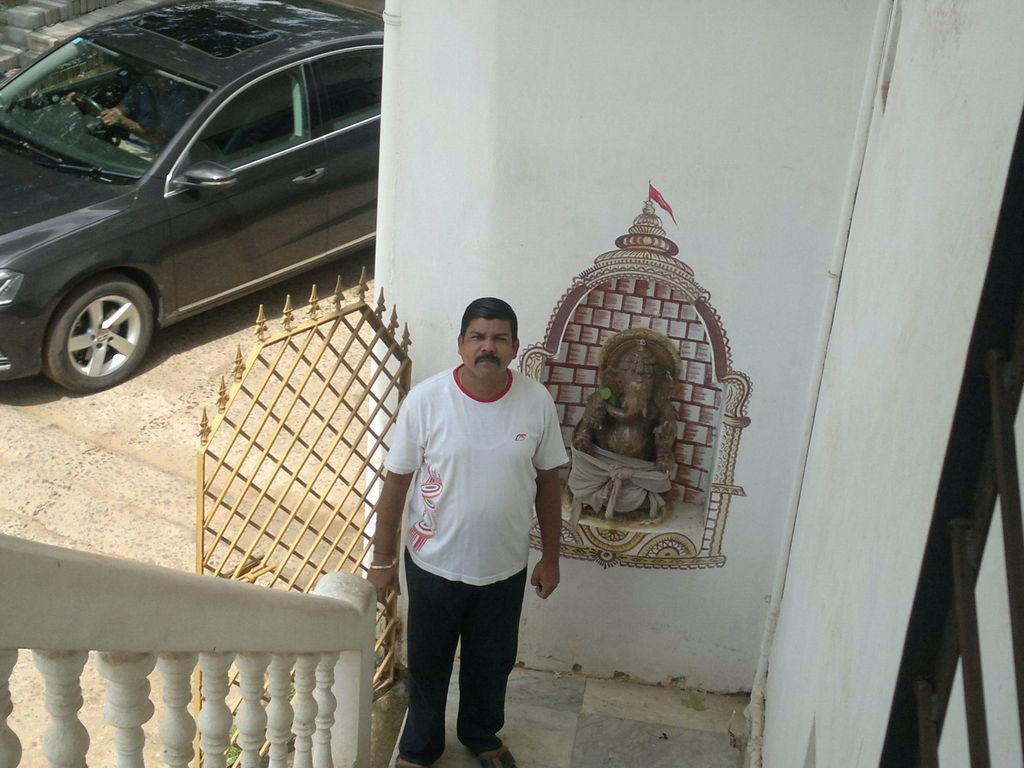What is the main subject in the image? There is a person standing in the image. What can be seen behind the person? There is a wall in the image. What is located near the wall? There is a car in the image. What type of surface is the car on? There is a road in the image. What is the entrance to the area? There is a gate in the image. What type of animal is wearing a collar on the shelf in the image? There is no animal wearing a collar on a shelf in the image. 